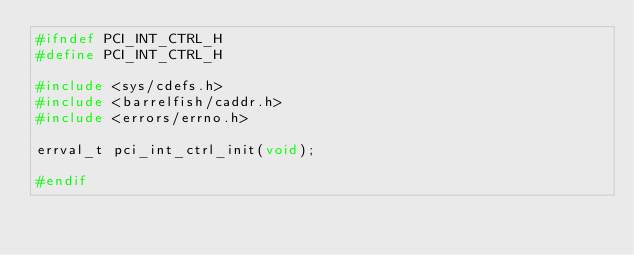<code> <loc_0><loc_0><loc_500><loc_500><_C_>#ifndef PCI_INT_CTRL_H
#define PCI_INT_CTRL_H

#include <sys/cdefs.h>
#include <barrelfish/caddr.h>
#include <errors/errno.h>

errval_t pci_int_ctrl_init(void);

#endif
</code> 